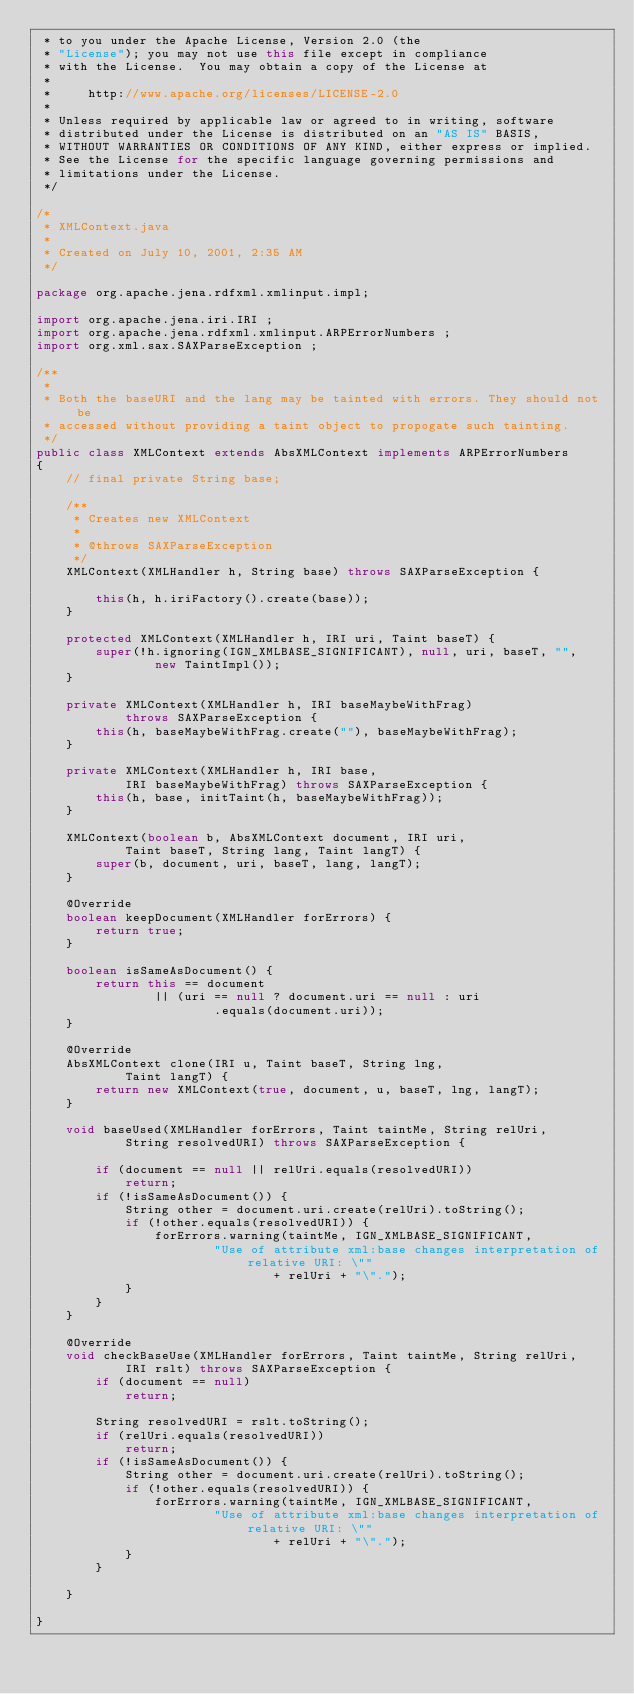<code> <loc_0><loc_0><loc_500><loc_500><_Java_> * to you under the Apache License, Version 2.0 (the
 * "License"); you may not use this file except in compliance
 * with the License.  You may obtain a copy of the License at
 *
 *     http://www.apache.org/licenses/LICENSE-2.0
 *
 * Unless required by applicable law or agreed to in writing, software
 * distributed under the License is distributed on an "AS IS" BASIS,
 * WITHOUT WARRANTIES OR CONDITIONS OF ANY KIND, either express or implied.
 * See the License for the specific language governing permissions and
 * limitations under the License.
 */

/*
 * XMLContext.java
 *
 * Created on July 10, 2001, 2:35 AM
 */

package org.apache.jena.rdfxml.xmlinput.impl;

import org.apache.jena.iri.IRI ;
import org.apache.jena.rdfxml.xmlinput.ARPErrorNumbers ;
import org.xml.sax.SAXParseException ;

/**
 * 
 * Both the baseURI and the lang may be tainted with errors. They should not be
 * accessed without providing a taint object to propogate such tainting.
 */
public class XMLContext extends AbsXMLContext implements ARPErrorNumbers
{
    // final private String base;

    /**
     * Creates new XMLContext
     * 
     * @throws SAXParseException
     */
    XMLContext(XMLHandler h, String base) throws SAXParseException {

        this(h, h.iriFactory().create(base));
    }

    protected XMLContext(XMLHandler h, IRI uri, Taint baseT) {
        super(!h.ignoring(IGN_XMLBASE_SIGNIFICANT), null, uri, baseT, "",
                new TaintImpl());
    }

    private XMLContext(XMLHandler h, IRI baseMaybeWithFrag)
            throws SAXParseException {
        this(h, baseMaybeWithFrag.create(""), baseMaybeWithFrag);
    }

    private XMLContext(XMLHandler h, IRI base,
            IRI baseMaybeWithFrag) throws SAXParseException {
        this(h, base, initTaint(h, baseMaybeWithFrag));
    }

    XMLContext(boolean b, AbsXMLContext document, IRI uri,
            Taint baseT, String lang, Taint langT) {
        super(b, document, uri, baseT, lang, langT);
    }

    @Override
    boolean keepDocument(XMLHandler forErrors) {
        return true;
    }

    boolean isSameAsDocument() {
        return this == document
                || (uri == null ? document.uri == null : uri
                        .equals(document.uri));
    }

    @Override
    AbsXMLContext clone(IRI u, Taint baseT, String lng,
            Taint langT) {
        return new XMLContext(true, document, u, baseT, lng, langT);
    }

    void baseUsed(XMLHandler forErrors, Taint taintMe, String relUri,
            String resolvedURI) throws SAXParseException {

        if (document == null || relUri.equals(resolvedURI))
            return;
        if (!isSameAsDocument()) {
            String other = document.uri.create(relUri).toString();
            if (!other.equals(resolvedURI)) {
                forErrors.warning(taintMe, IGN_XMLBASE_SIGNIFICANT,
                        "Use of attribute xml:base changes interpretation of relative URI: \""
                                + relUri + "\".");
            }
        }
    }

    @Override
    void checkBaseUse(XMLHandler forErrors, Taint taintMe, String relUri,
            IRI rslt) throws SAXParseException {
        if (document == null)
            return;

        String resolvedURI = rslt.toString();
        if (relUri.equals(resolvedURI))
            return;
        if (!isSameAsDocument()) {
            String other = document.uri.create(relUri).toString();
            if (!other.equals(resolvedURI)) {
                forErrors.warning(taintMe, IGN_XMLBASE_SIGNIFICANT,
                        "Use of attribute xml:base changes interpretation of relative URI: \""
                                + relUri + "\".");
            }
        }

    }

}
</code> 